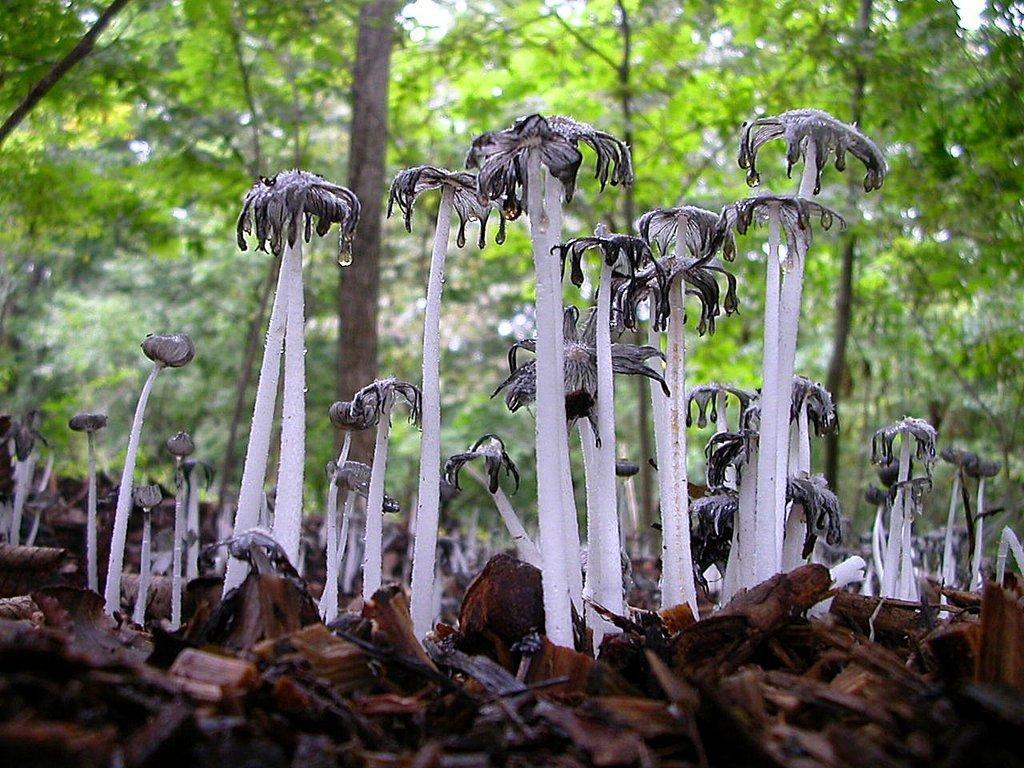How would you summarize this image in a sentence or two? In this image there are mushrooms on the ground, there are trees. 